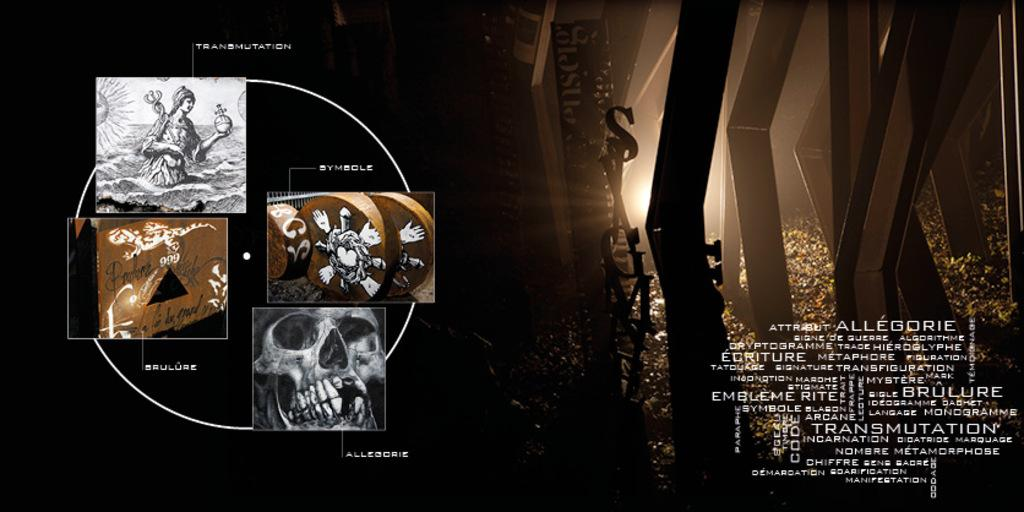<image>
Describe the image concisely. Symbols for Allegorie can be seen on a dark poster 